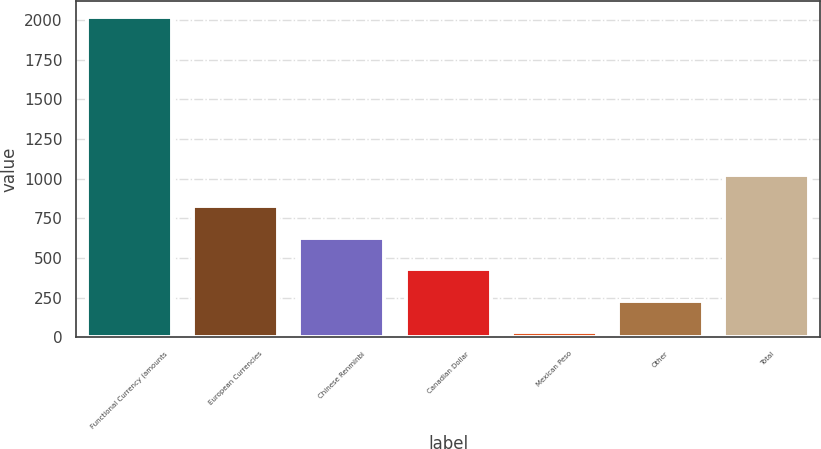Convert chart to OTSL. <chart><loc_0><loc_0><loc_500><loc_500><bar_chart><fcel>Functional Currency (amounts<fcel>European Currencies<fcel>Chinese Renminbi<fcel>Canadian Dollar<fcel>Mexican Peso<fcel>Other<fcel>Total<nl><fcel>2018<fcel>825.98<fcel>627.31<fcel>428.64<fcel>31.3<fcel>229.97<fcel>1024.65<nl></chart> 